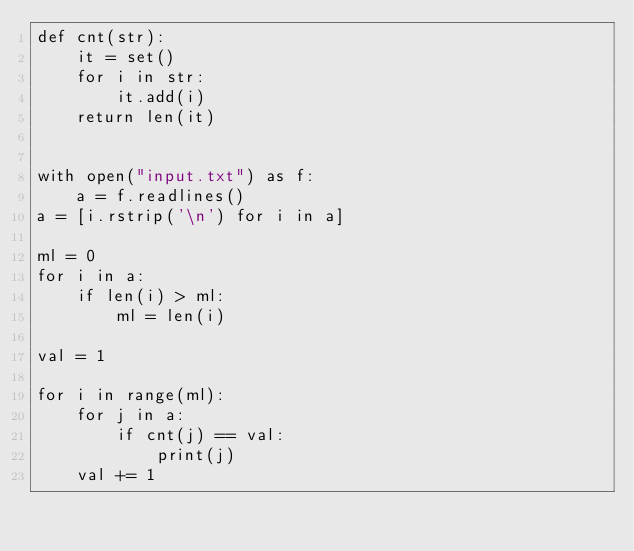Convert code to text. <code><loc_0><loc_0><loc_500><loc_500><_Python_>def cnt(str):
    it = set()
    for i in str:
        it.add(i)
    return len(it)


with open("input.txt") as f:
    a = f.readlines()
a = [i.rstrip('\n') for i in a]

ml = 0
for i in a:
    if len(i) > ml:
        ml = len(i)

val = 1

for i in range(ml):
    for j in a:
        if cnt(j) == val:
            print(j)
    val += 1
</code> 